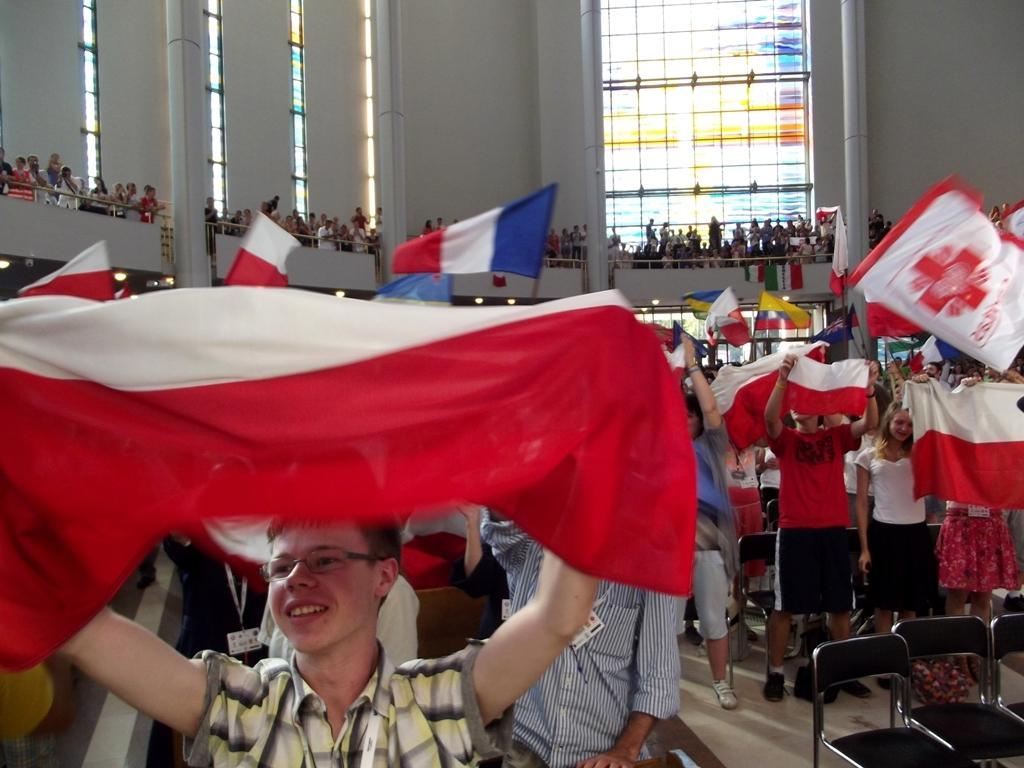In one or two sentences, can you explain what this image depicts? In this picture there are people those who are standing in the center of the image, by holding flags in there hands and there are other people those who are standing in the background area of the image and there are glass windows in the background area of the image, there are chairs in the image. 